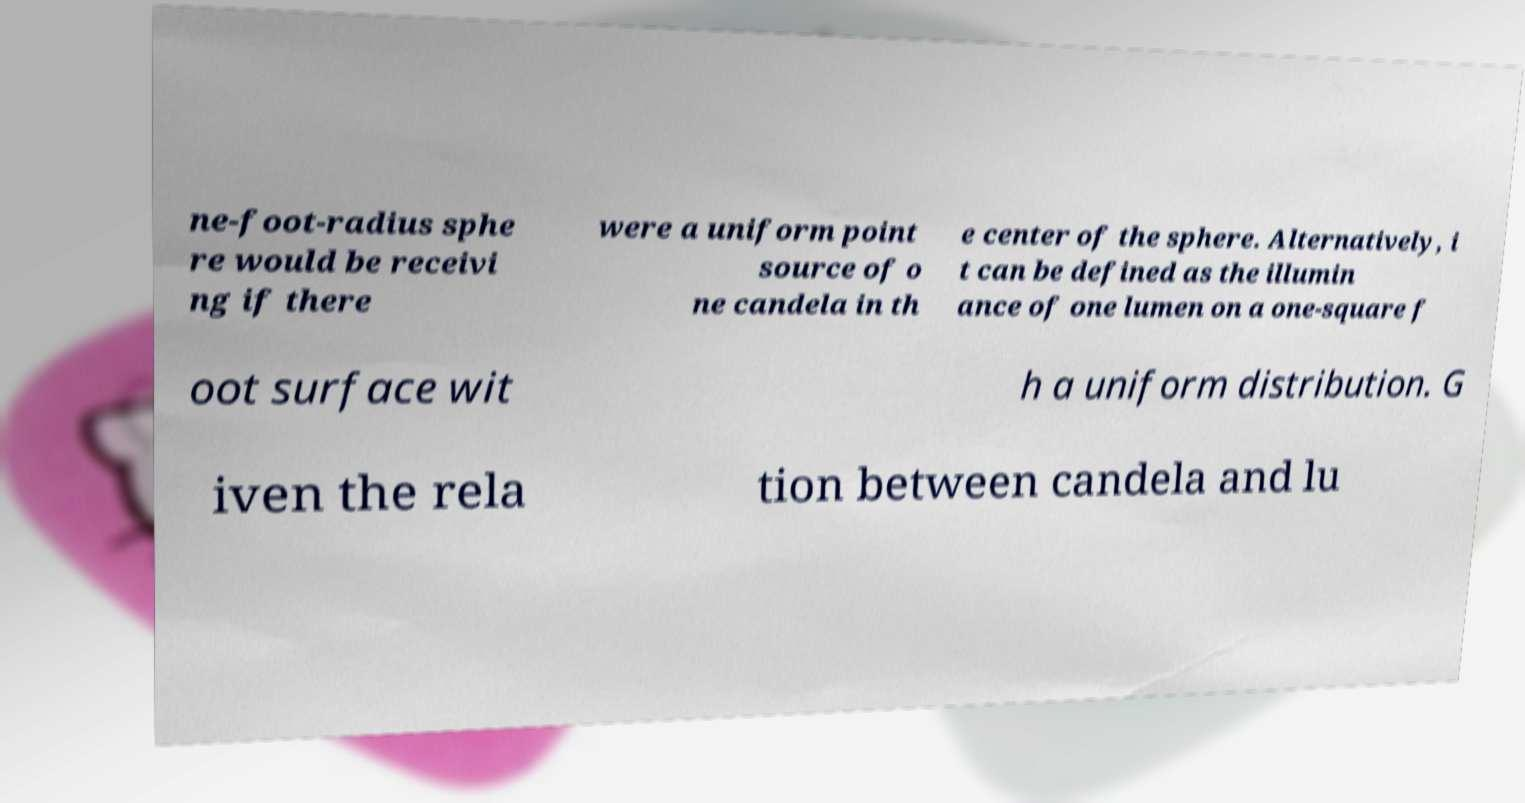Please identify and transcribe the text found in this image. ne-foot-radius sphe re would be receivi ng if there were a uniform point source of o ne candela in th e center of the sphere. Alternatively, i t can be defined as the illumin ance of one lumen on a one-square f oot surface wit h a uniform distribution. G iven the rela tion between candela and lu 